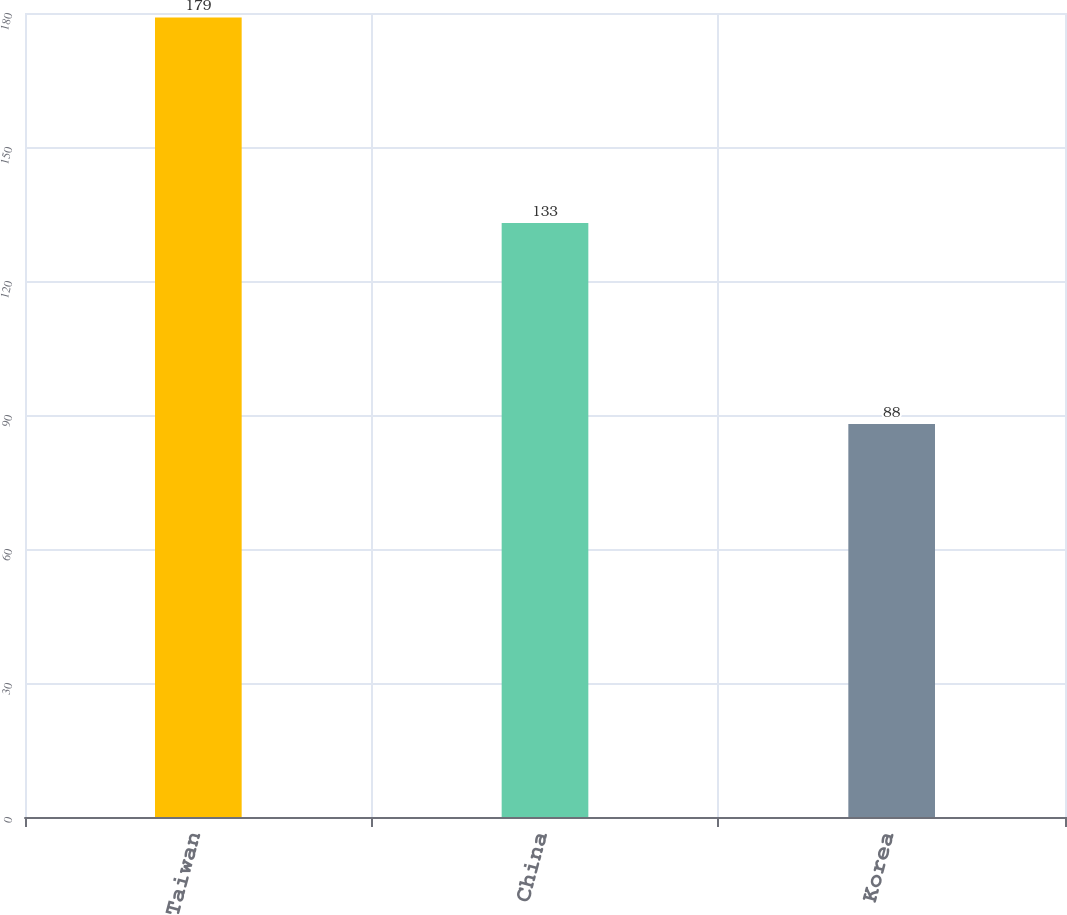Convert chart to OTSL. <chart><loc_0><loc_0><loc_500><loc_500><bar_chart><fcel>Taiwan<fcel>China<fcel>Korea<nl><fcel>179<fcel>133<fcel>88<nl></chart> 